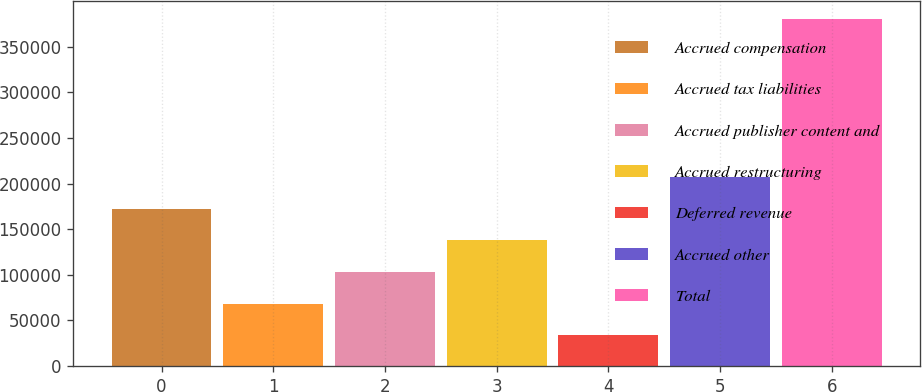Convert chart. <chart><loc_0><loc_0><loc_500><loc_500><bar_chart><fcel>Accrued compensation<fcel>Accrued tax liabilities<fcel>Accrued publisher content and<fcel>Accrued restructuring<fcel>Deferred revenue<fcel>Accrued other<fcel>Total<nl><fcel>172570<fcel>68386.8<fcel>103115<fcel>137842<fcel>33659<fcel>207298<fcel>380937<nl></chart> 